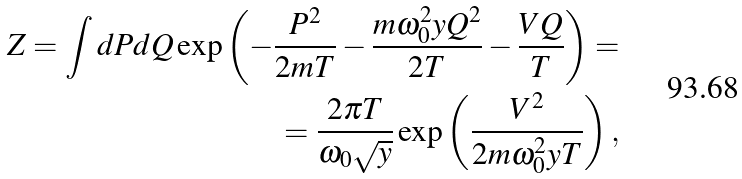Convert formula to latex. <formula><loc_0><loc_0><loc_500><loc_500>Z = \int d P d Q \exp \left ( - \frac { P ^ { 2 } } { 2 m T } - \frac { m \omega _ { 0 } ^ { 2 } y Q ^ { 2 } } { 2 T } - \frac { V Q } { T } \right ) = \\ = \frac { 2 \pi T } { \omega _ { 0 } \sqrt { y } } \exp \left ( \frac { V ^ { 2 } } { 2 m \omega _ { 0 } ^ { 2 } y T } \right ) ,</formula> 